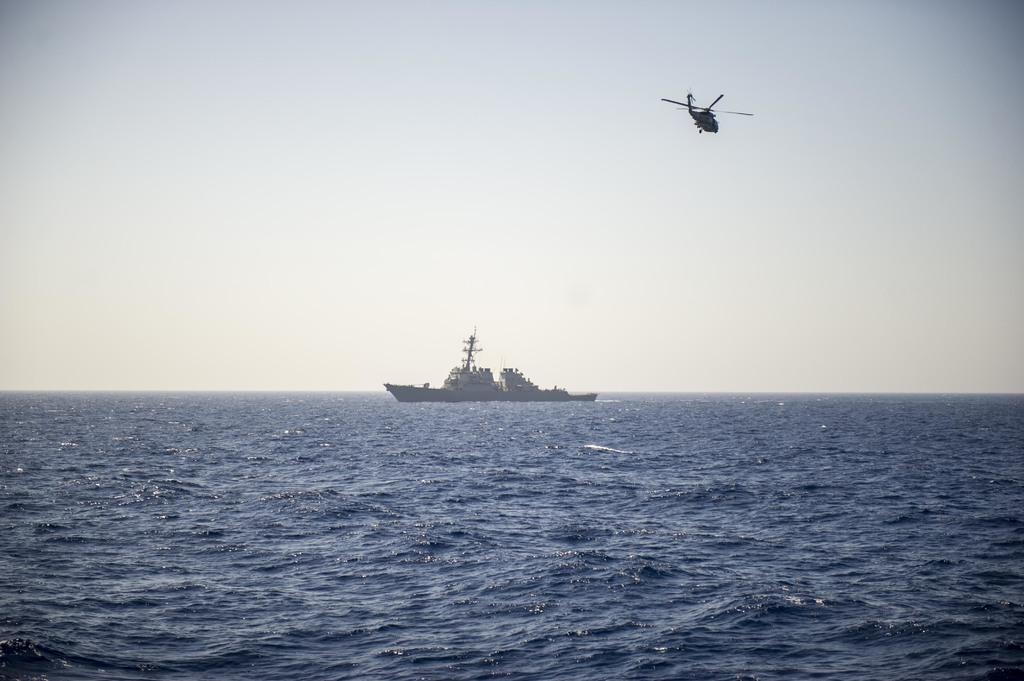What is located in the water in the image? There is a ship in the water in the image. What is located in the air in the image? There is a helicopter in the air in the image. What can be seen in the background of the image? The sky is visible in the background of the image. Where is the pencil located in the image? There is no pencil present in the image. What type of food is being served in the lunchroom in the image? There is no lunchroom present in the image. 